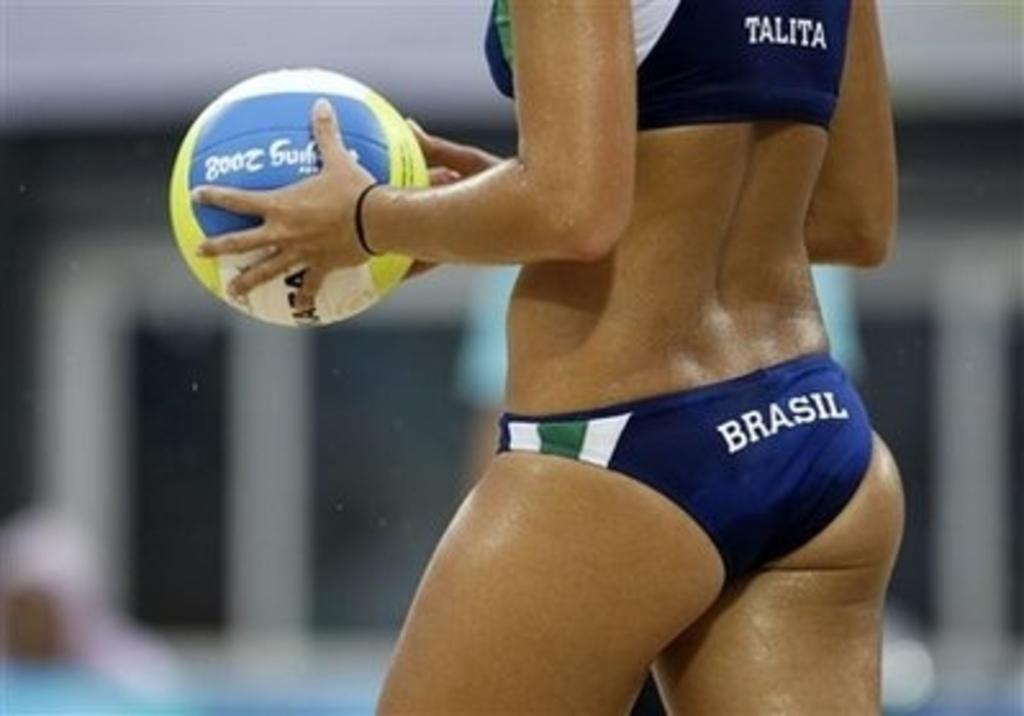What is the woman in the image doing? The woman is standing in the image and holding a ball. Can you describe the background of the image? The background of the image is blurry. What type of pickle is the woman holding in the image? There is no pickle present in the image; the woman is holding a ball. Can you describe the space environment in the image? The image does not depict a space environment; it is a woman standing with a ball in a blurry background. 